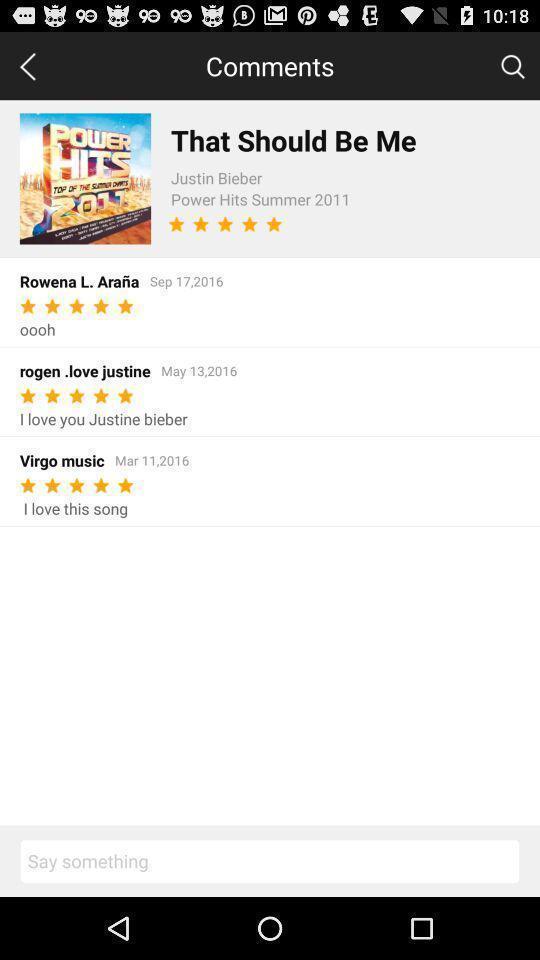Describe the key features of this screenshot. Page showing comments under a music album. 